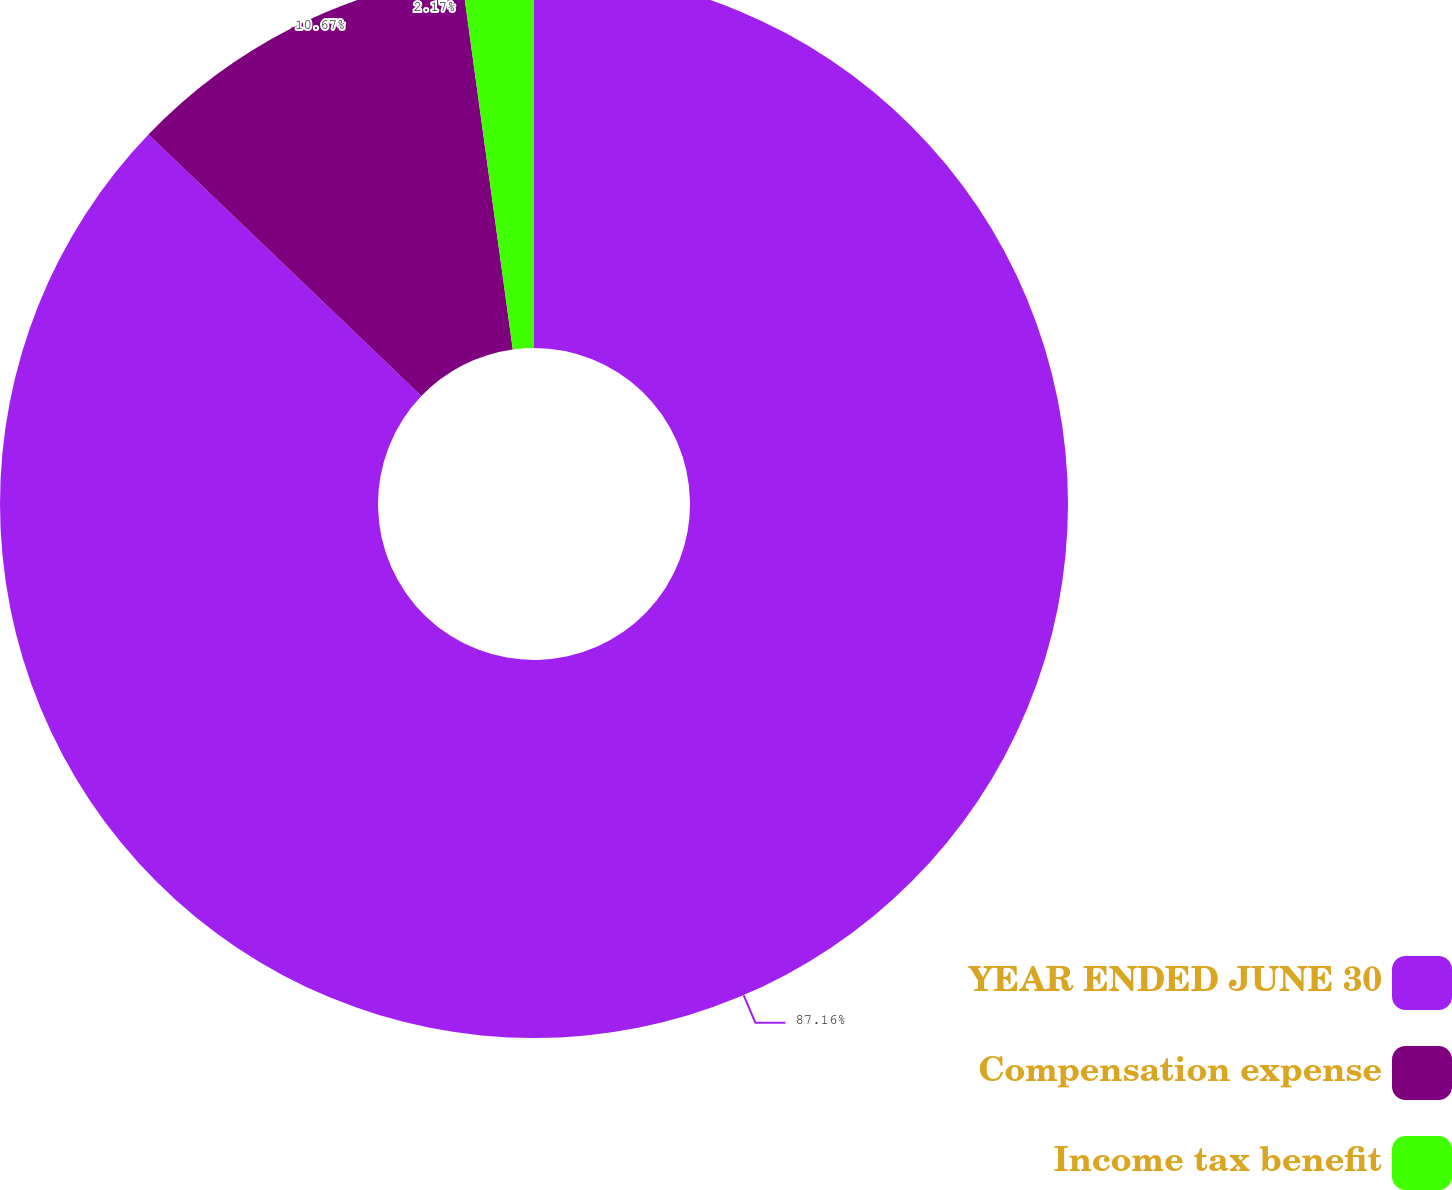Convert chart to OTSL. <chart><loc_0><loc_0><loc_500><loc_500><pie_chart><fcel>YEAR ENDED JUNE 30<fcel>Compensation expense<fcel>Income tax benefit<nl><fcel>87.16%<fcel>10.67%<fcel>2.17%<nl></chart> 